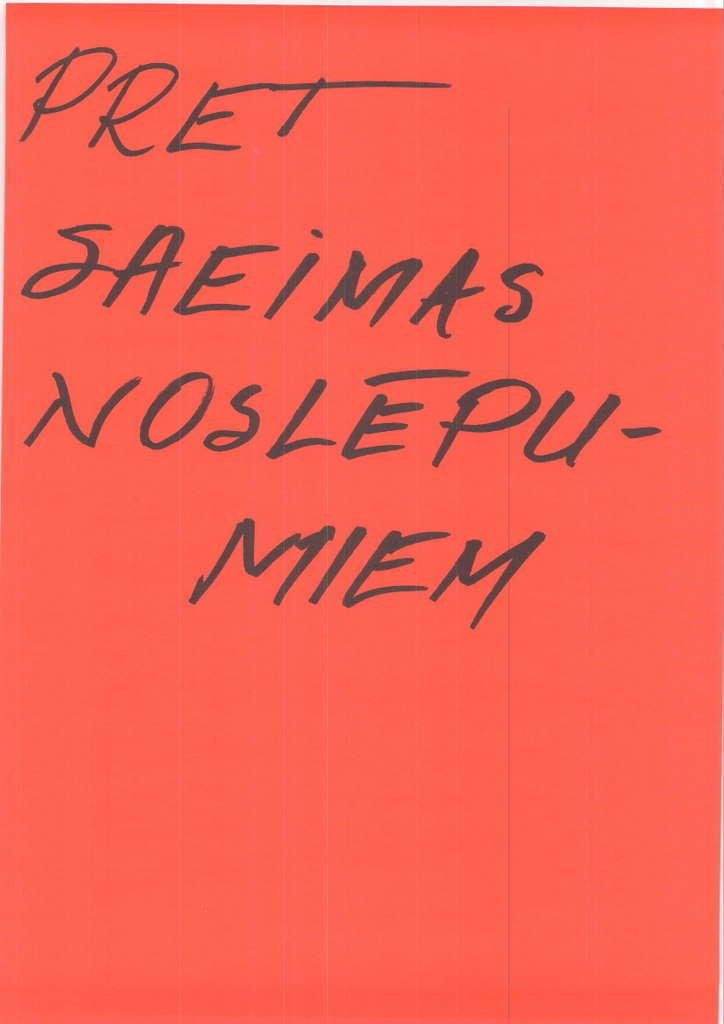<image>
Relay a brief, clear account of the picture shown. Red piece of paper that says "Pret Saeimas Noslepu-Miem" on it. 